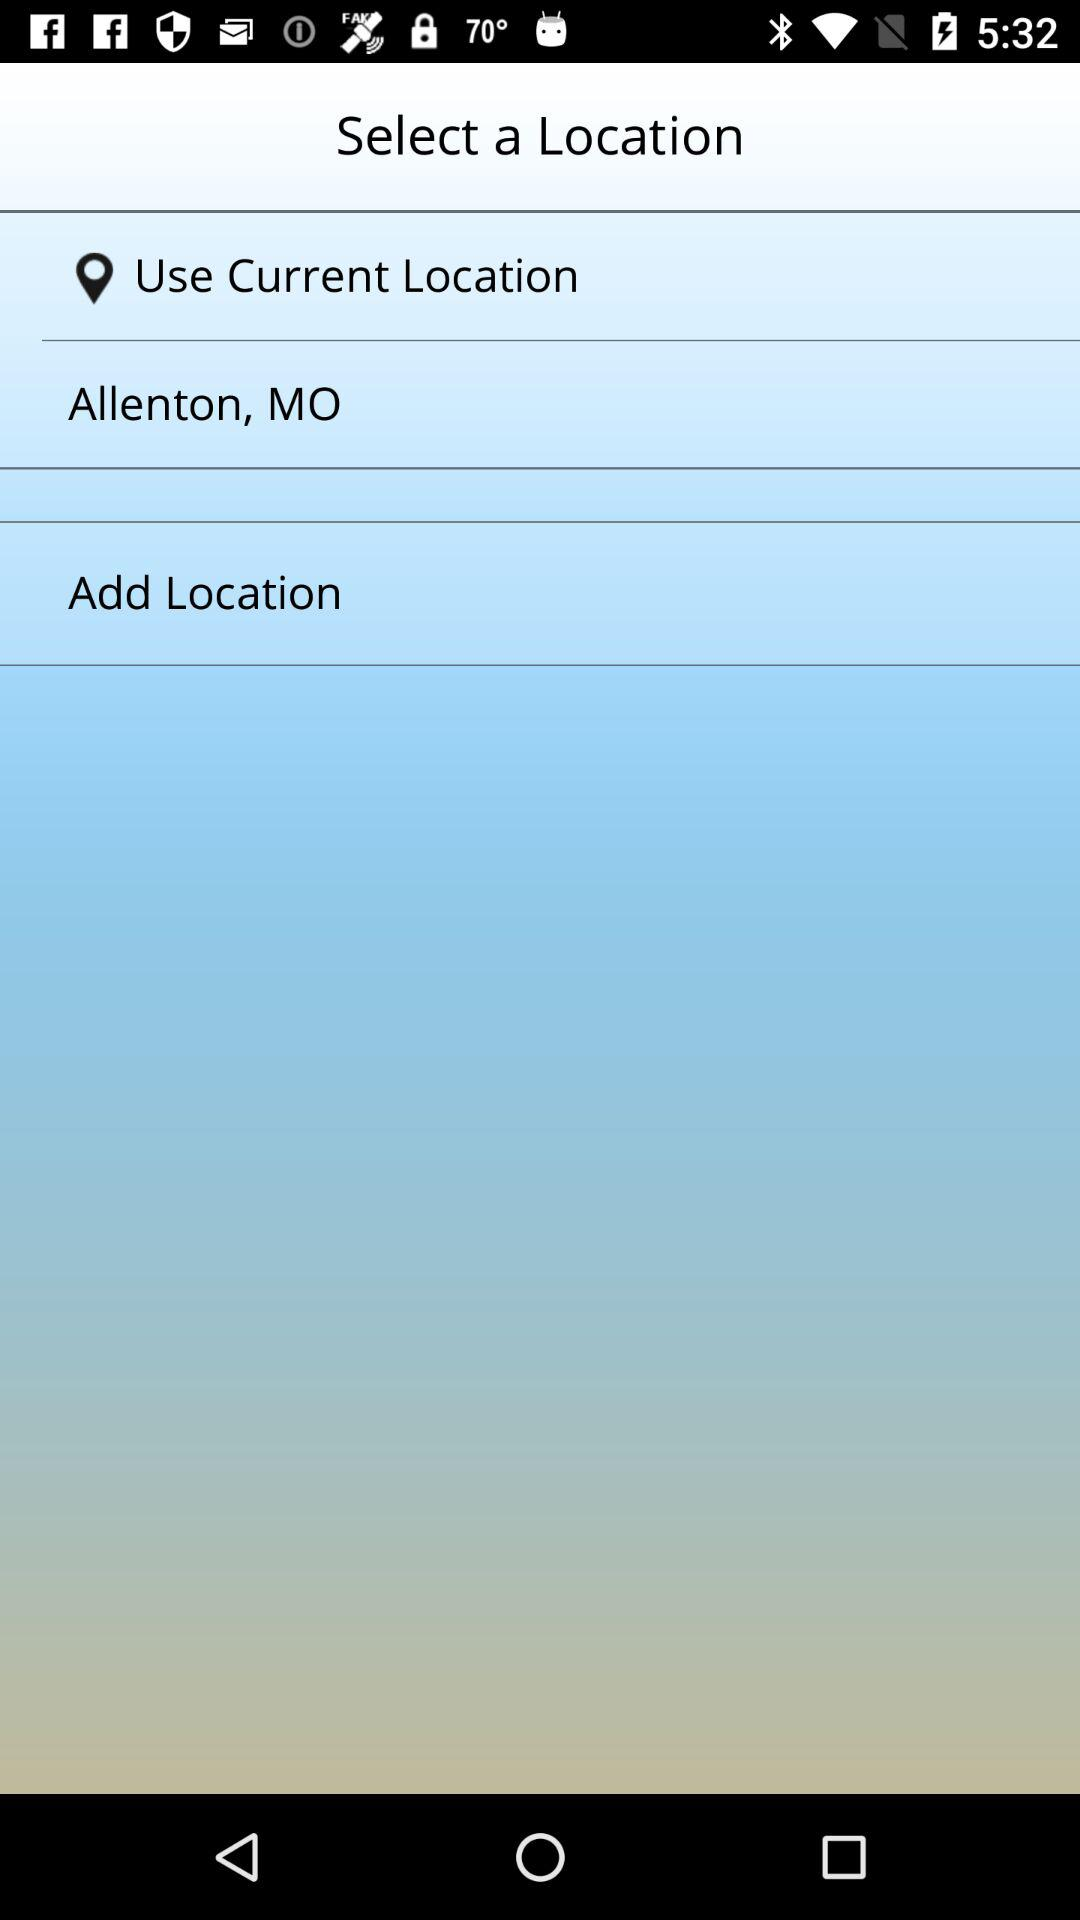What is the current location? The current location is Allenton, MO. 